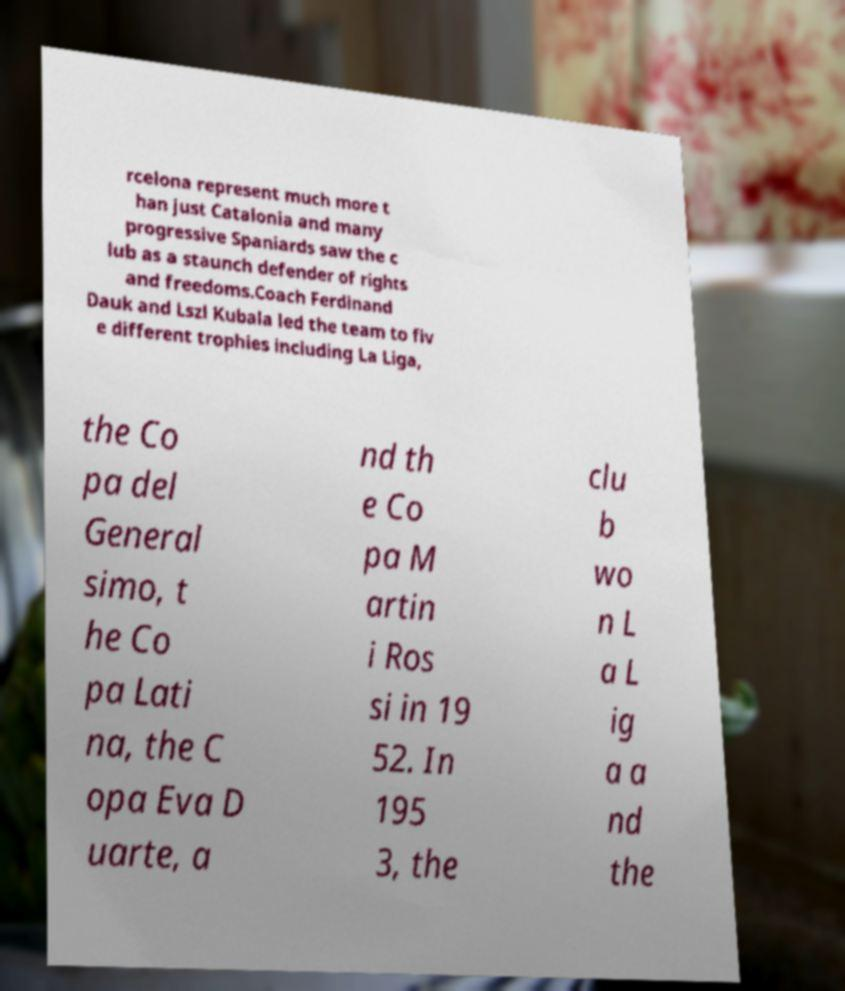Could you extract and type out the text from this image? rcelona represent much more t han just Catalonia and many progressive Spaniards saw the c lub as a staunch defender of rights and freedoms.Coach Ferdinand Dauk and Lszl Kubala led the team to fiv e different trophies including La Liga, the Co pa del General simo, t he Co pa Lati na, the C opa Eva D uarte, a nd th e Co pa M artin i Ros si in 19 52. In 195 3, the clu b wo n L a L ig a a nd the 